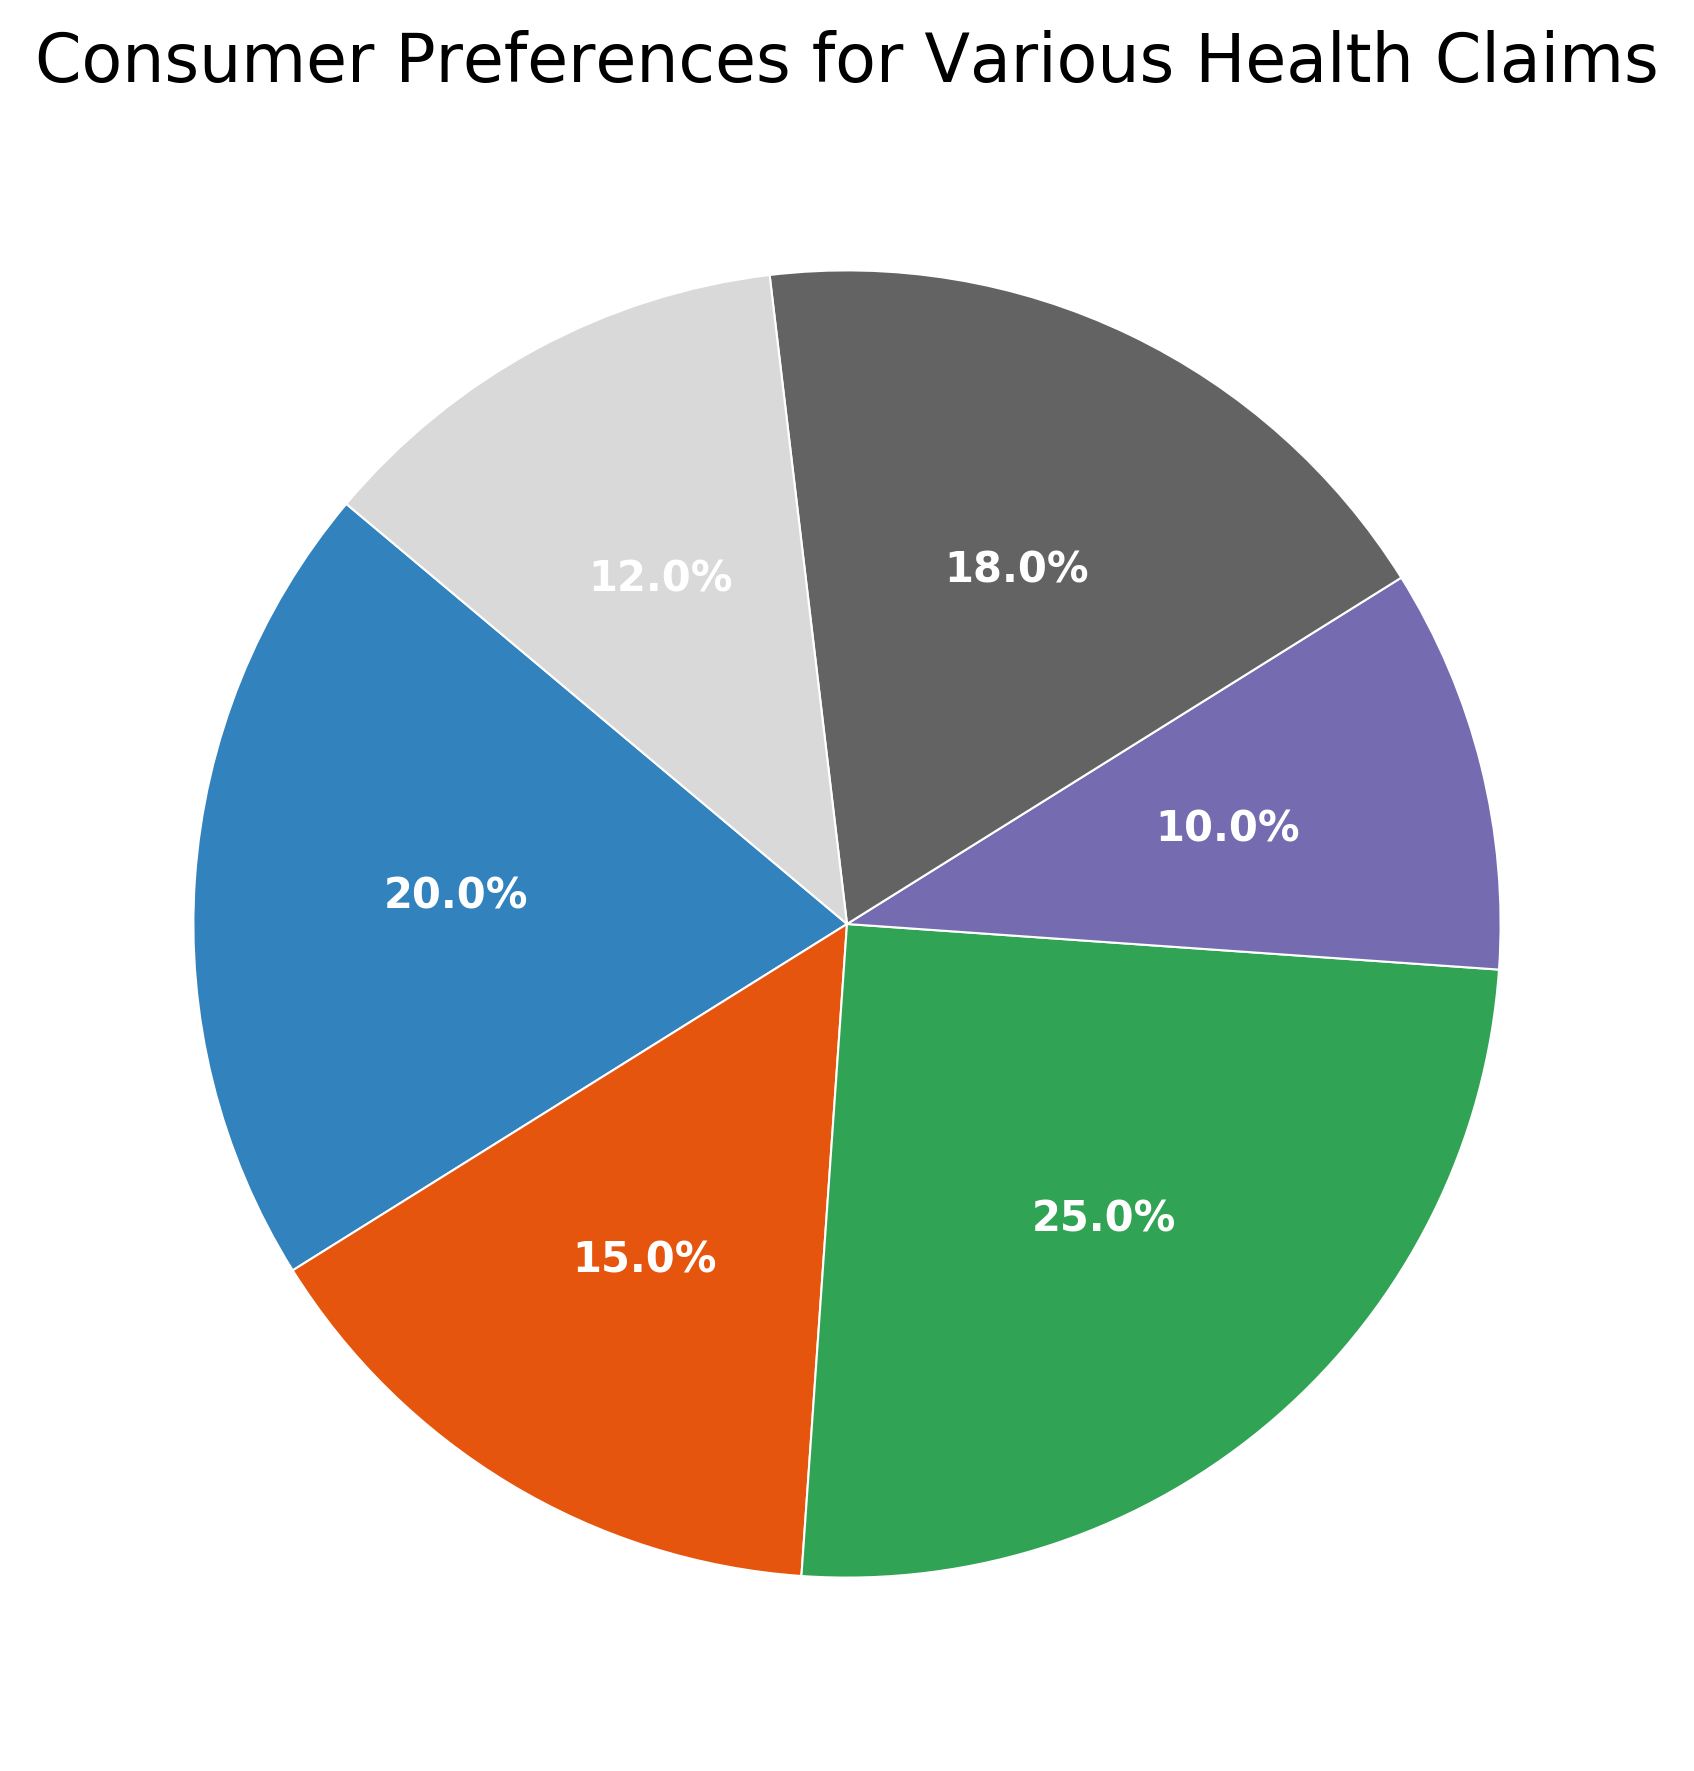what is the most preferred health claim on food labels? The most preferred health claim can be identified by looking at the section of the pie chart with the largest percentage. Here, the "Organic" claim has the highest percentage at 25%.
Answer: Organic what is the least preferred health claim on food labels? The least preferred health claim is the one with the smallest segment of the pie chart. In this case, "Gluten-Free" has the smallest segment at 10%.
Answer: Gluten-Free How much more preferred is "Low Fat" than "Gluten-Free"? To calculate how much more preferred "Low Fat" is compared to "Gluten-Free," subtract the percentage of "Gluten-Free" from the percentage of "Low Fat": 20% - 10% = 10%.
Answer: 10% which health claim is more preferred: "High Fiber" or "No Added Sugar"? By comparing the sizes of the pie chart segments, "No Added Sugar" has a larger percentage (18%) than "High Fiber" which is 15%.
Answer: No Added Sugar What is the combined preference percentage for "Low Fat" and "High Protein"? Add the percentages of "Low Fat" (20%) and "High Protein" (12%): 20% + 12% = 32%.
Answer: 32% what percentage of consumers prefer either "Organic" or "No Added Sugar"? To find the percentage of consumers who prefer either "Organic" or "No Added Sugar," add the percentages of both: 25% (Organic) + 18% (No Added Sugar) = 43%.
Answer: 43% Which two health claims are equally preferred according to the chart? By examining the chart, no two health claims have the same percentage, so no two health claims are equally preferred.
Answer: None Rank the health claims from most to least preferred. To rank the health claims, list them in order of their percentages from highest to lowest: Organic (25%), Low Fat (20%), No Added Sugar (18%), High Fiber (15%), High Protein (12%), Gluten-Free (10%).
Answer: Organic > Low Fat > No Added Sugar > High Fiber > High Protein > Gluten-Free What is the average preference percentage for all the health claims combined? To calculate the average preference percentage, add all the percentages and divide by the number of claims: (20% + 15% + 25% + 10% + 18% + 12%) / 6 = 100% / 6 ≈ 16.67%.
Answer: 16.67% how much more do consumers prefer "Organic" compared to "High Protein"? Subtract the percentage of "High Protein" from "Organic": 25% - 12% = 13%.
Answer: 13% 